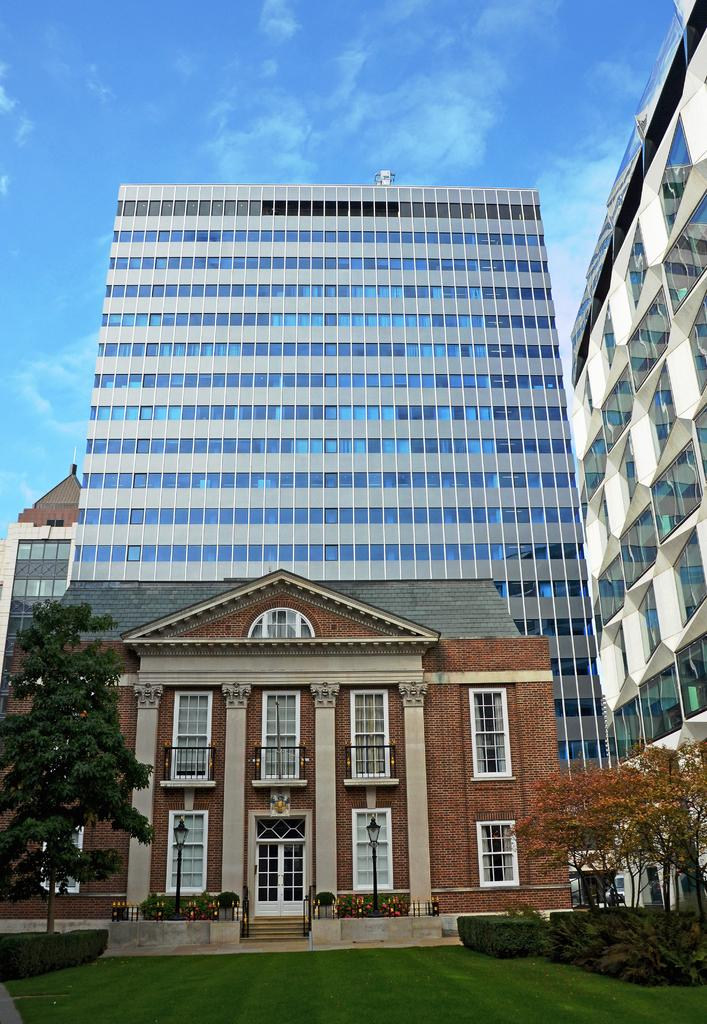What type of vegetation is in the foreground of the image? There is a small grass and trees in the foreground of the image. Can you describe the vegetation in more detail? The vegetation in the foreground consists of small grass and trees. What can be seen in the background of the image? There are buildings in the background of the image. Is there a basin visible in the image? There is no basin present in the image. What type of approval is being given in the image? There is no indication of any approval being given in the image. 